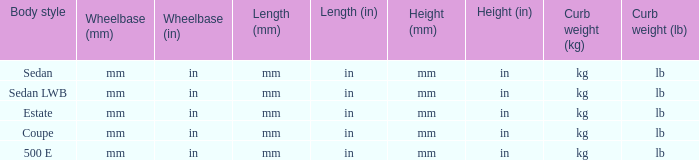What's the curb weight of the model with a wheelbase of mm (in) and height of mm (in) mm (in) (4Matic)? Kg ( lb ), kg (lb). 